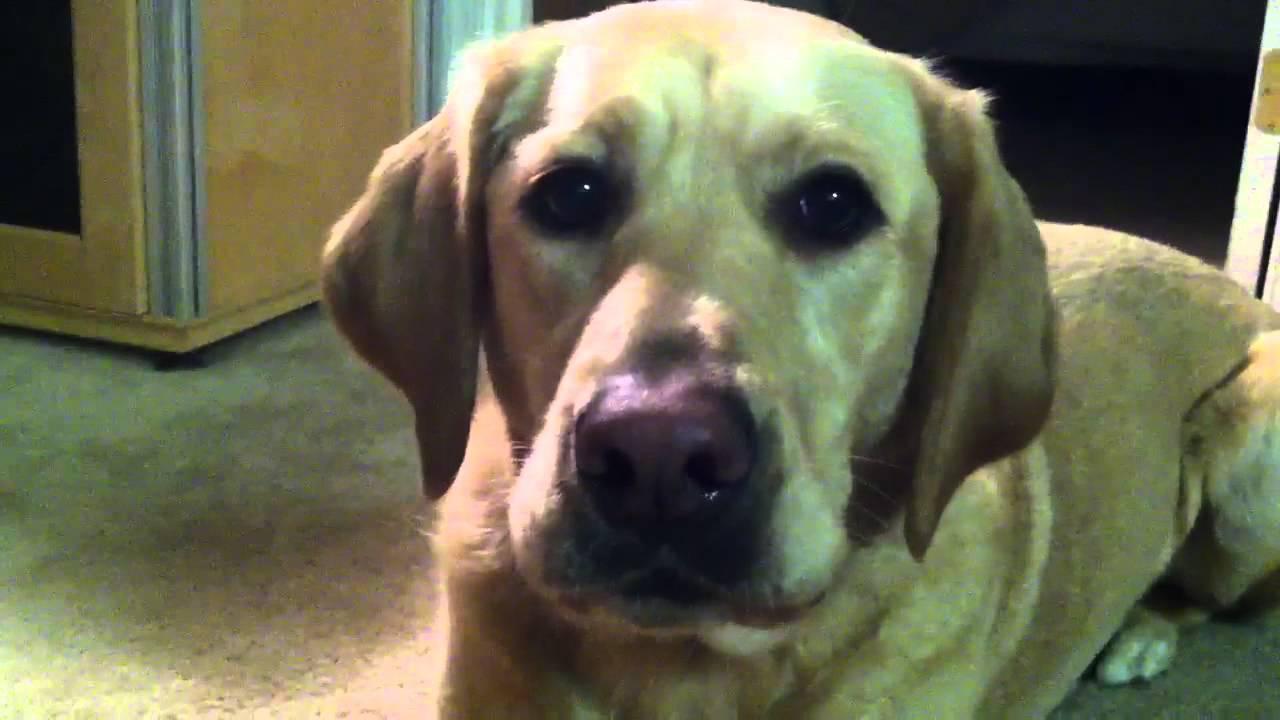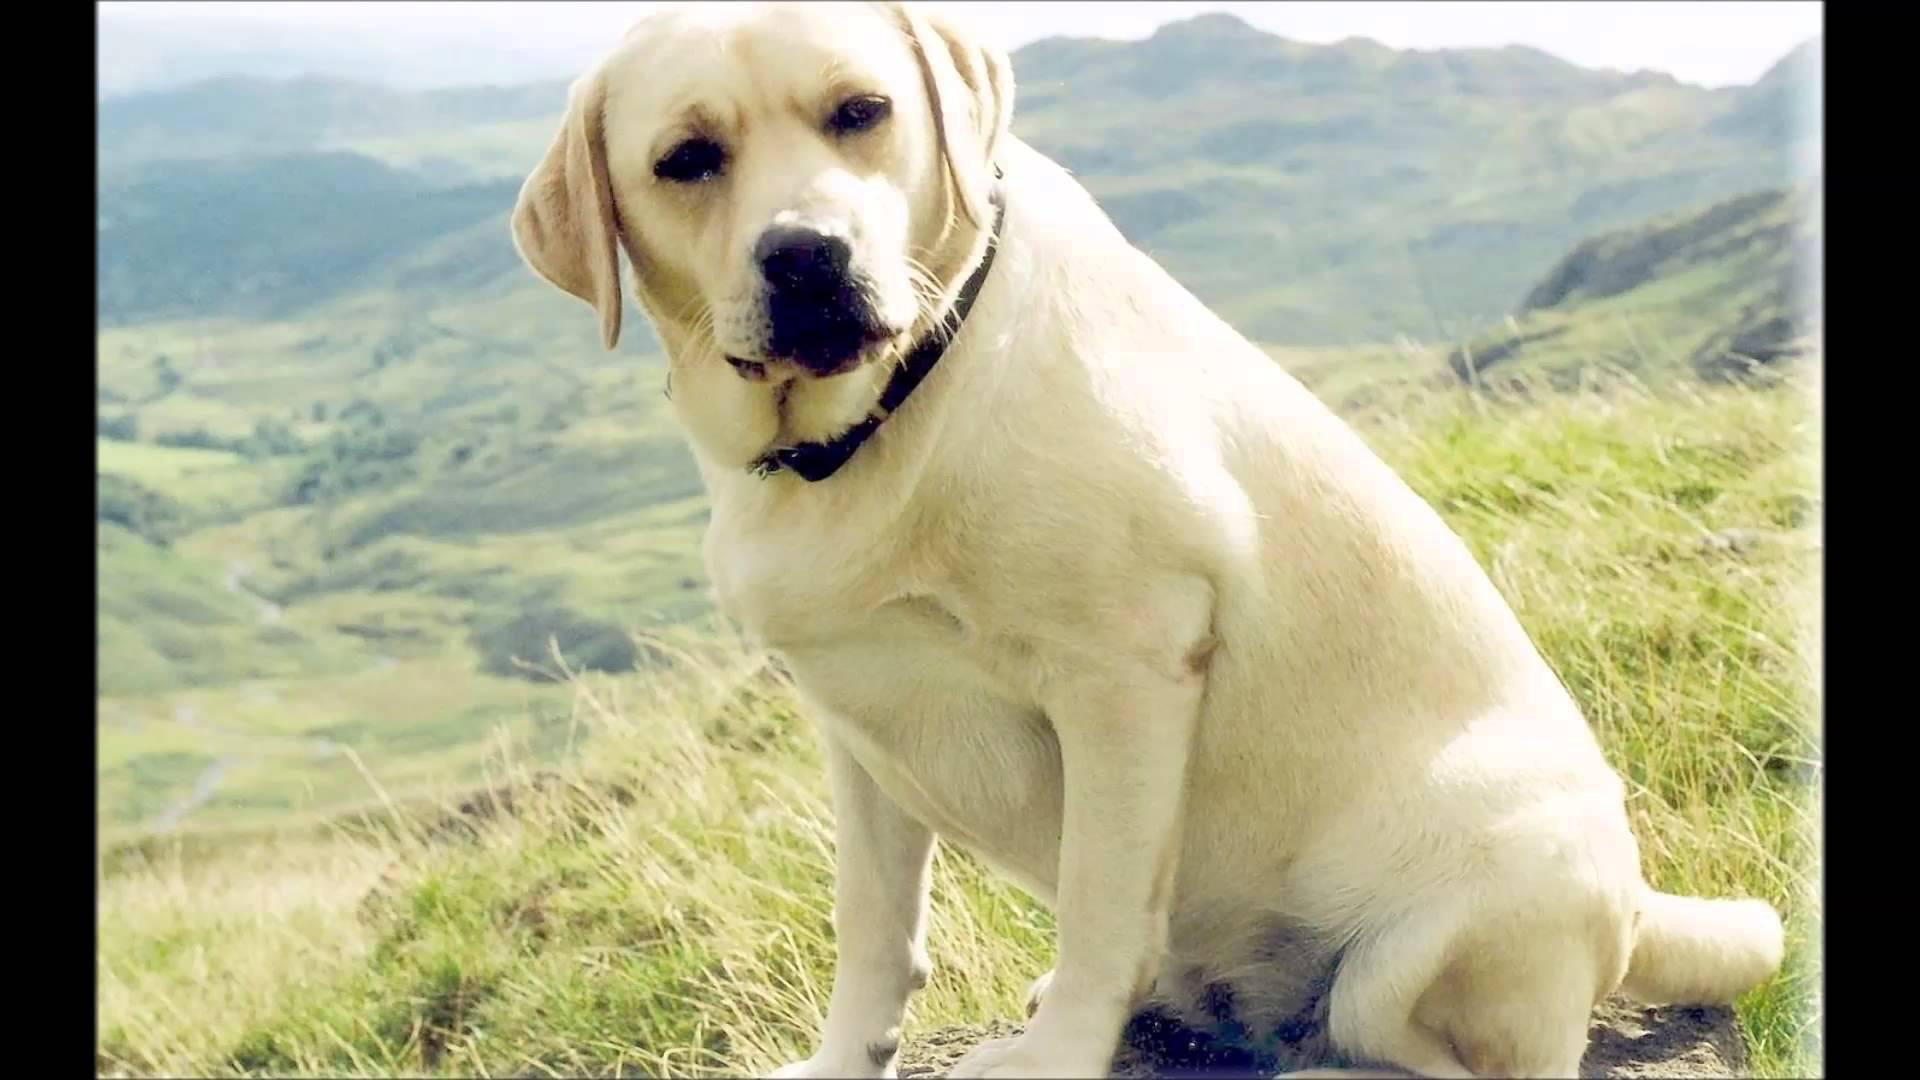The first image is the image on the left, the second image is the image on the right. Given the left and right images, does the statement "The dog on the right is on the grass." hold true? Answer yes or no. Yes. The first image is the image on the left, the second image is the image on the right. Considering the images on both sides, is "Only one image shows a dog with mouth opened." valid? Answer yes or no. No. 